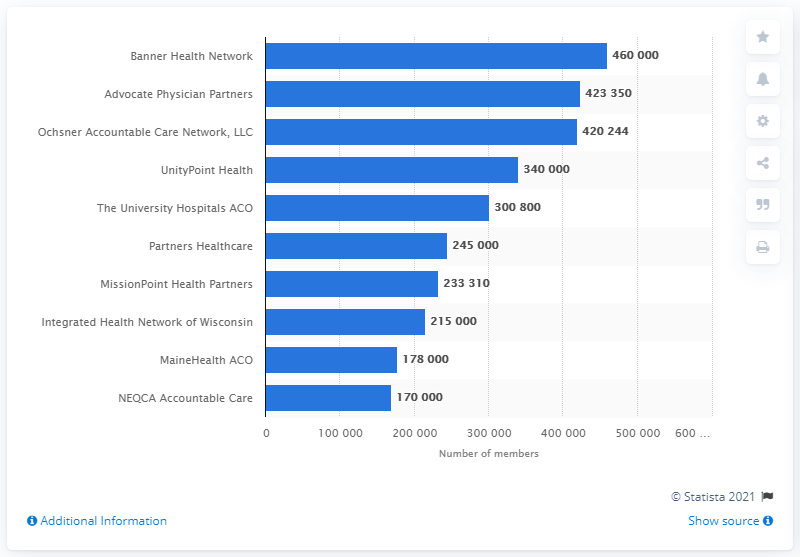Mention a couple of crucial points in this snapshot. Banner Health Network had approximately 460,000 members as of [insert date]. In 2016, Banner Health Network was the largest Accountable Care Organization (ACO) in the United States. In 2016, the largest ACO in the United States was Banner Health Network. 